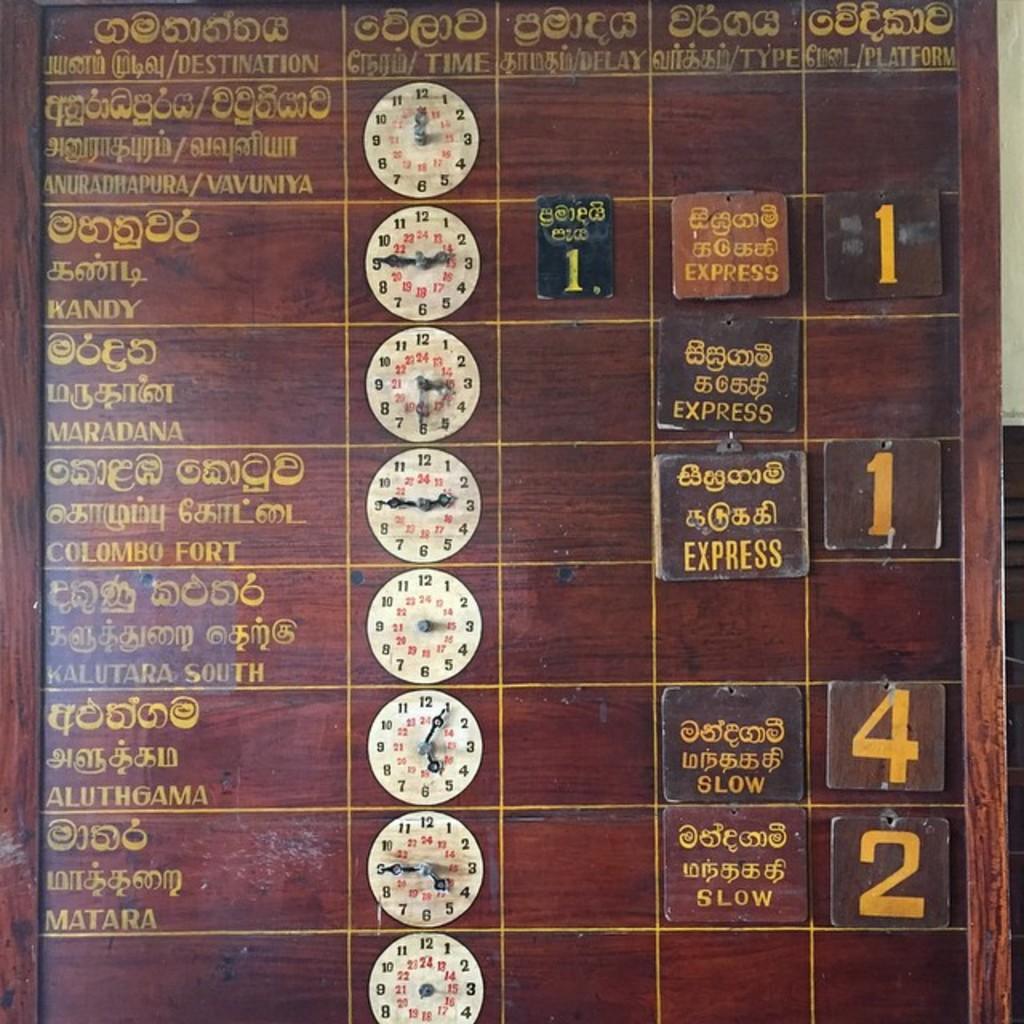What's the lowest digit number you can see?
Offer a terse response. 1. 